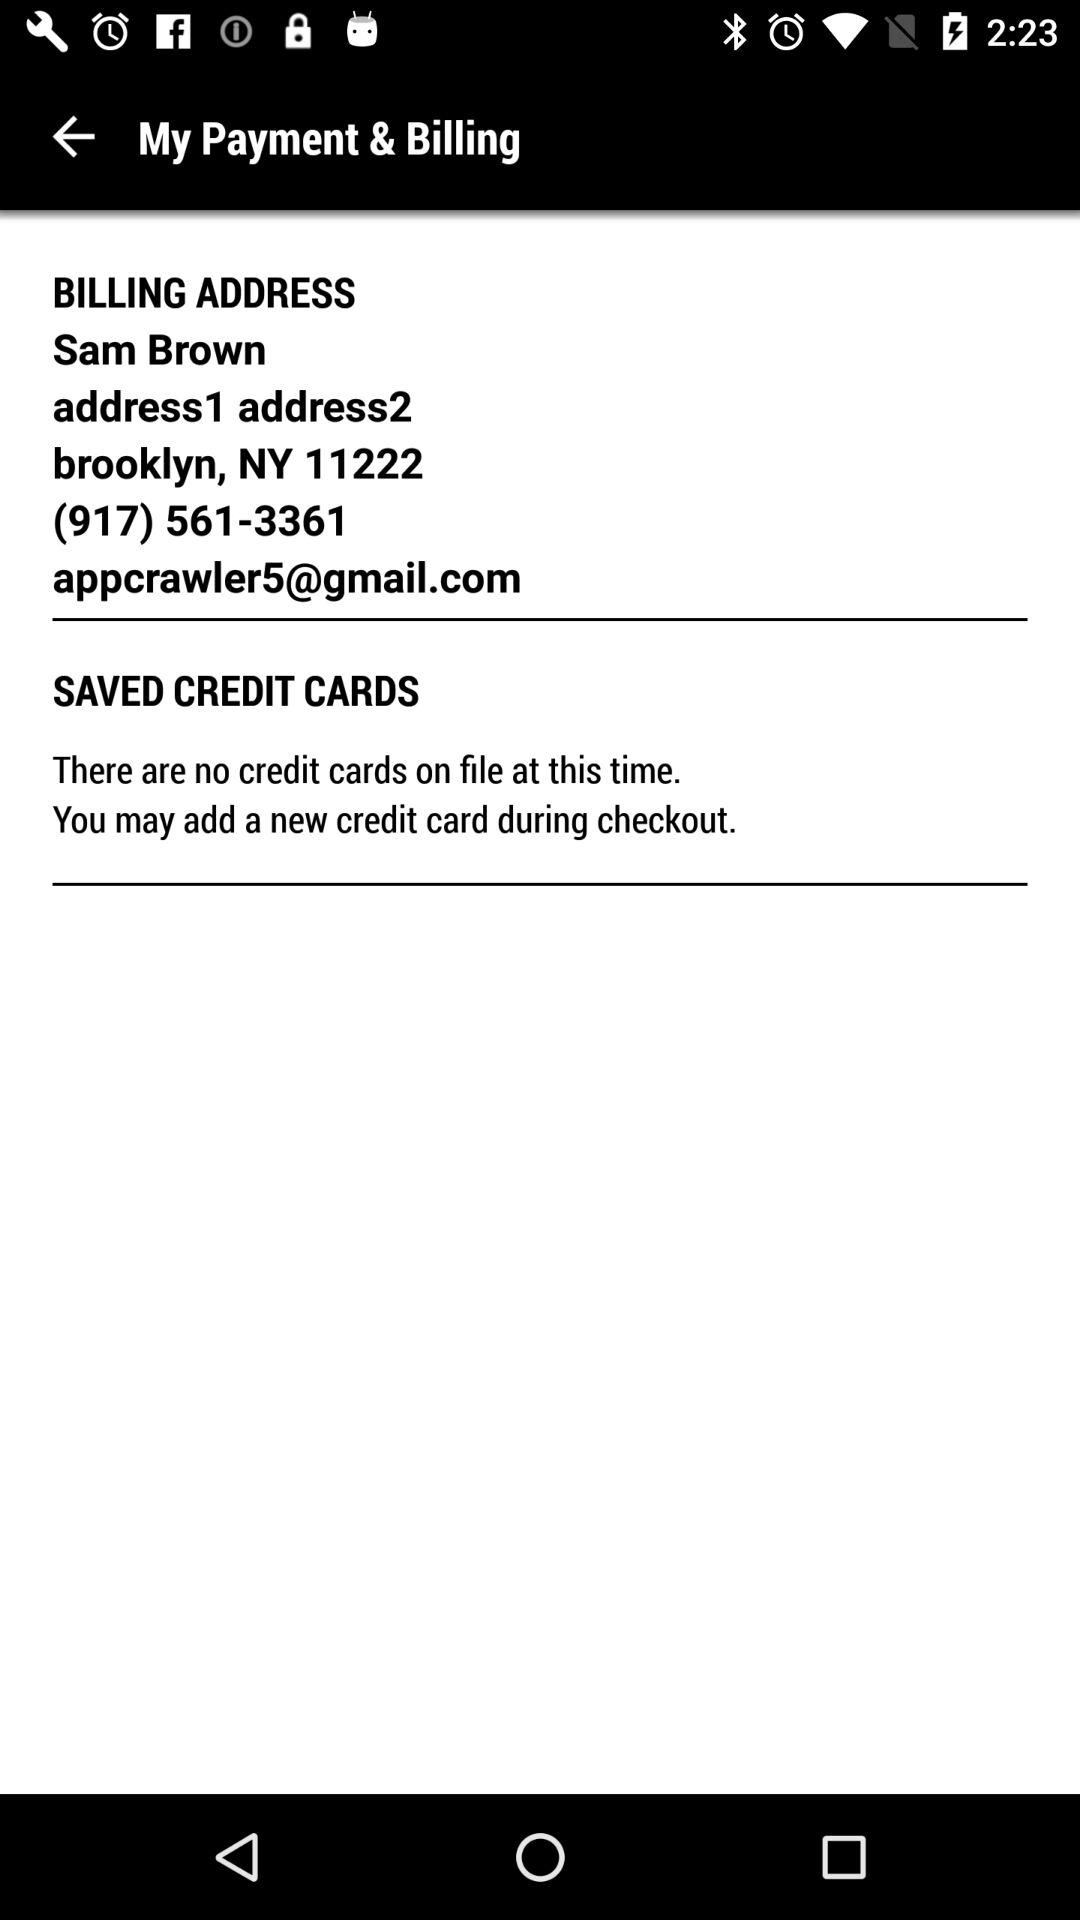How many digits are in the user's phone number?
Answer the question using a single word or phrase. 10 